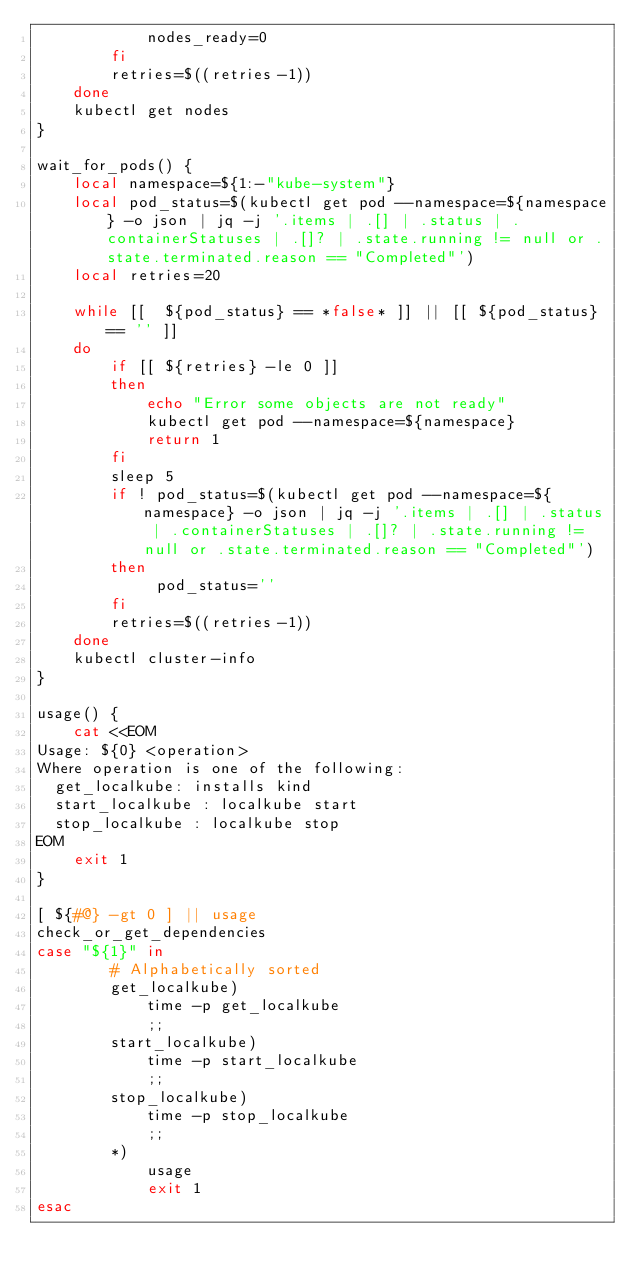<code> <loc_0><loc_0><loc_500><loc_500><_Bash_>            nodes_ready=0
        fi
        retries=$((retries-1))
    done
    kubectl get nodes
}

wait_for_pods() {
    local namespace=${1:-"kube-system"}
    local pod_status=$(kubectl get pod --namespace=${namespace} -o json | jq -j '.items | .[] | .status | .containerStatuses | .[]? | .state.running != null or .state.terminated.reason == "Completed"')
    local retries=20

    while [[  ${pod_status} == *false* ]] || [[ ${pod_status} == '' ]]
    do
        if [[ ${retries} -le 0 ]]
        then
            echo "Error some objects are not ready"
            kubectl get pod --namespace=${namespace}
            return 1
        fi
        sleep 5
        if ! pod_status=$(kubectl get pod --namespace=${namespace} -o json | jq -j '.items | .[] | .status | .containerStatuses | .[]? | .state.running != null or .state.terminated.reason == "Completed"')
        then
             pod_status=''
        fi
        retries=$((retries-1))
    done
    kubectl cluster-info
}

usage() {
    cat <<EOM
Usage: ${0} <operation>
Where operation is one of the following:
  get_localkube: installs kind
  start_localkube : localkube start
  stop_localkube : localkube stop
EOM
    exit 1
}

[ ${#@} -gt 0 ] || usage
check_or_get_dependencies
case "${1}" in
        # Alphabetically sorted
        get_localkube)
            time -p get_localkube
            ;;
        start_localkube)
            time -p start_localkube
            ;;
        stop_localkube)
            time -p stop_localkube
            ;;
        *)
            usage
            exit 1
esac
</code> 